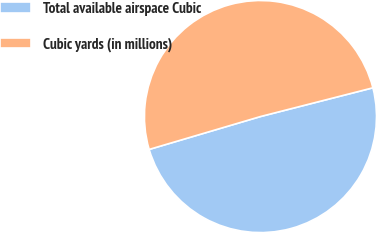Convert chart. <chart><loc_0><loc_0><loc_500><loc_500><pie_chart><fcel>Total available airspace Cubic<fcel>Cubic yards (in millions)<nl><fcel>49.41%<fcel>50.59%<nl></chart> 